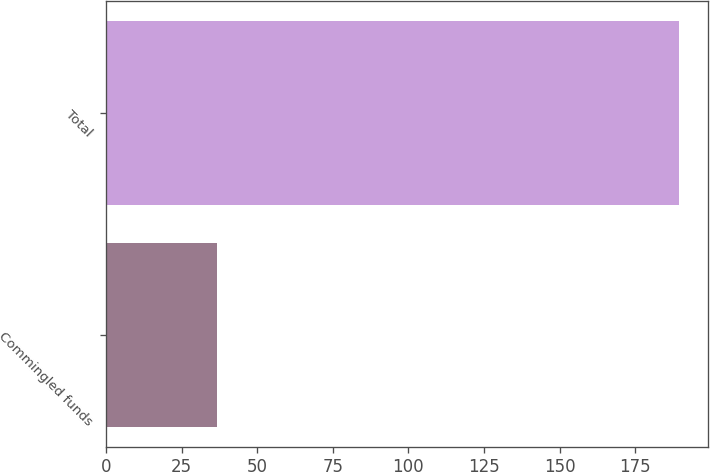<chart> <loc_0><loc_0><loc_500><loc_500><bar_chart><fcel>Commingled funds<fcel>Total<nl><fcel>36.6<fcel>189.4<nl></chart> 